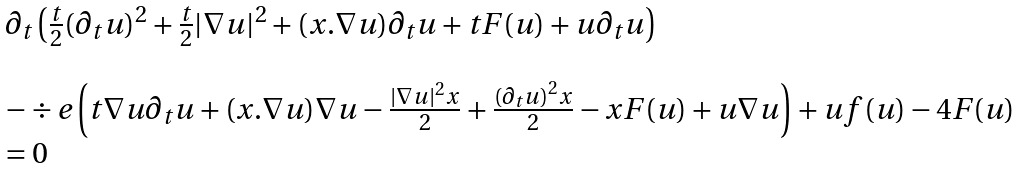<formula> <loc_0><loc_0><loc_500><loc_500>\begin{array} { l } \partial _ { t } \left ( \frac { t } { 2 } ( \partial _ { t } u ) ^ { 2 } + \frac { t } { 2 } | \nabla u | ^ { 2 } + ( x . \nabla u ) \partial _ { t } u + t F ( u ) + u \partial _ { t } u \right ) \\ \\ - \div e \left ( t \nabla u \partial _ { t } u + ( x . \nabla u ) \nabla u - \frac { | \nabla u | ^ { 2 } x } { 2 } + \frac { ( \partial _ { t } u ) ^ { 2 } x } { 2 } - x F ( u ) + u \nabla u \right ) + u f ( u ) - 4 F ( u ) \\ = 0 \end{array}</formula> 